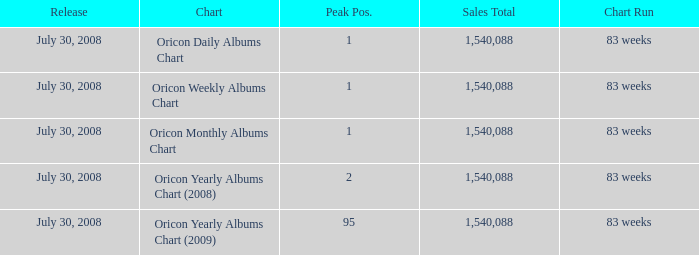How much Peak Position has Sales Total larger than 1,540,088? 0.0. 